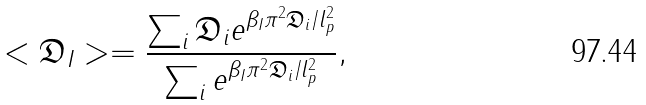Convert formula to latex. <formula><loc_0><loc_0><loc_500><loc_500>< \mathfrak { D } _ { I } > = \frac { \sum _ { i } \mathfrak { D } _ { i } e ^ { \beta _ { I } \pi ^ { 2 } \mathfrak { D } _ { i } / l _ { p } ^ { 2 } } } { \sum _ { i } e ^ { \beta _ { I } \pi ^ { 2 } \mathfrak { D } _ { i } / l _ { p } ^ { 2 } } } ,</formula> 